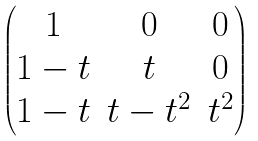<formula> <loc_0><loc_0><loc_500><loc_500>\begin{pmatrix} 1 & 0 & 0 \\ 1 - t & t & 0 \\ 1 - t & t - t ^ { 2 } & t ^ { 2 } \end{pmatrix}</formula> 